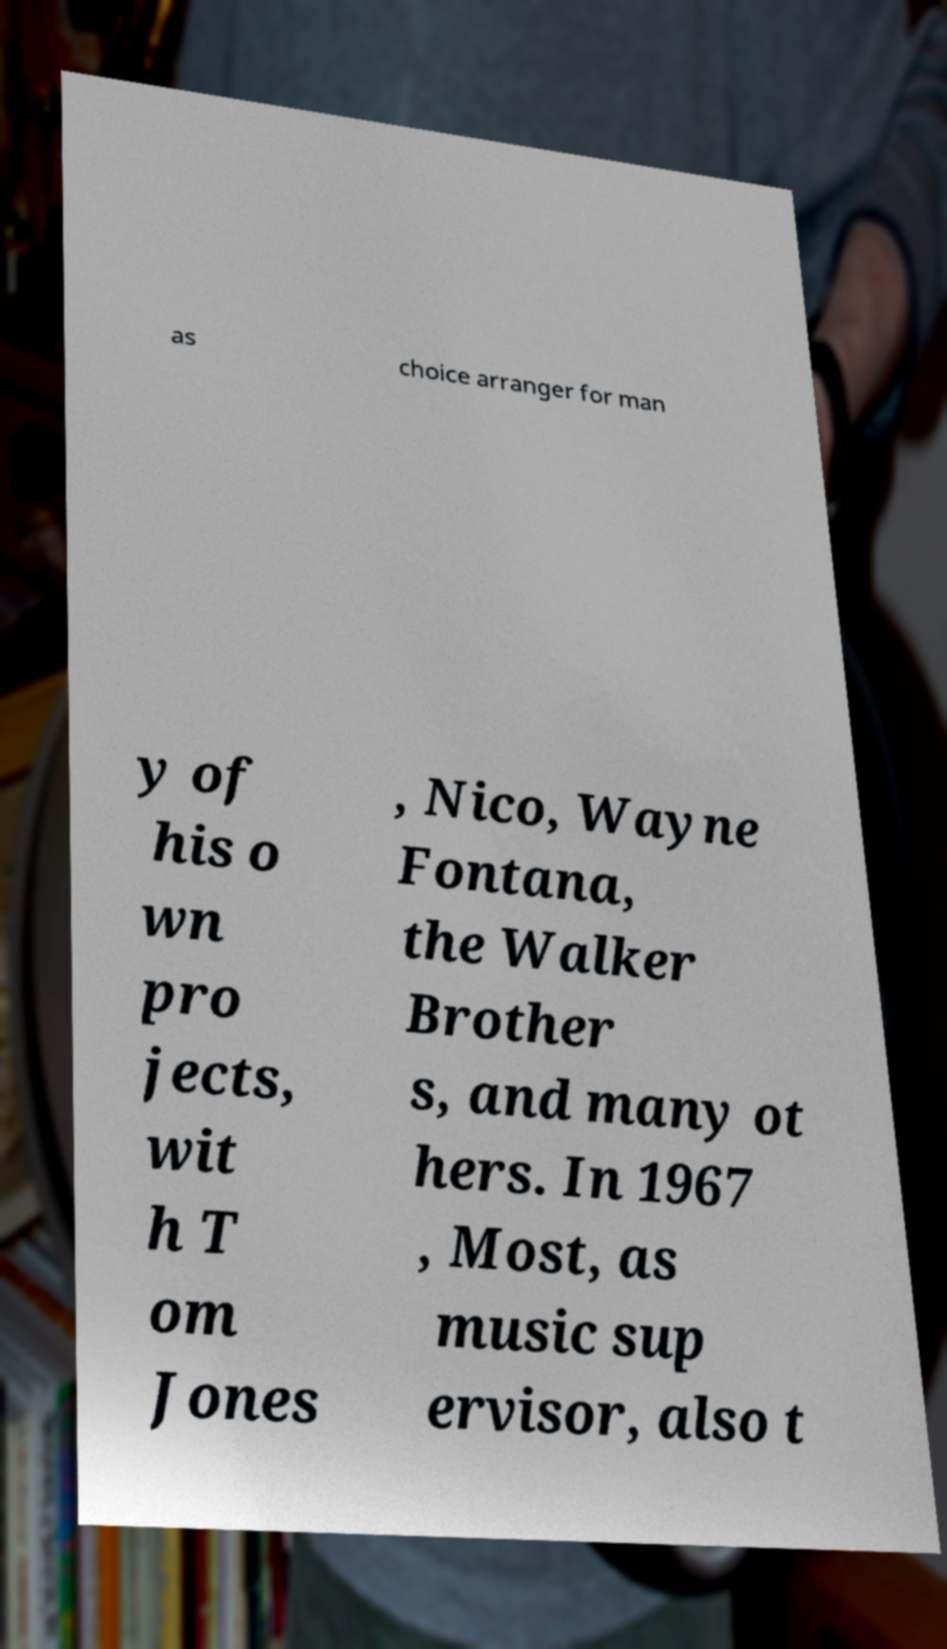I need the written content from this picture converted into text. Can you do that? as choice arranger for man y of his o wn pro jects, wit h T om Jones , Nico, Wayne Fontana, the Walker Brother s, and many ot hers. In 1967 , Most, as music sup ervisor, also t 